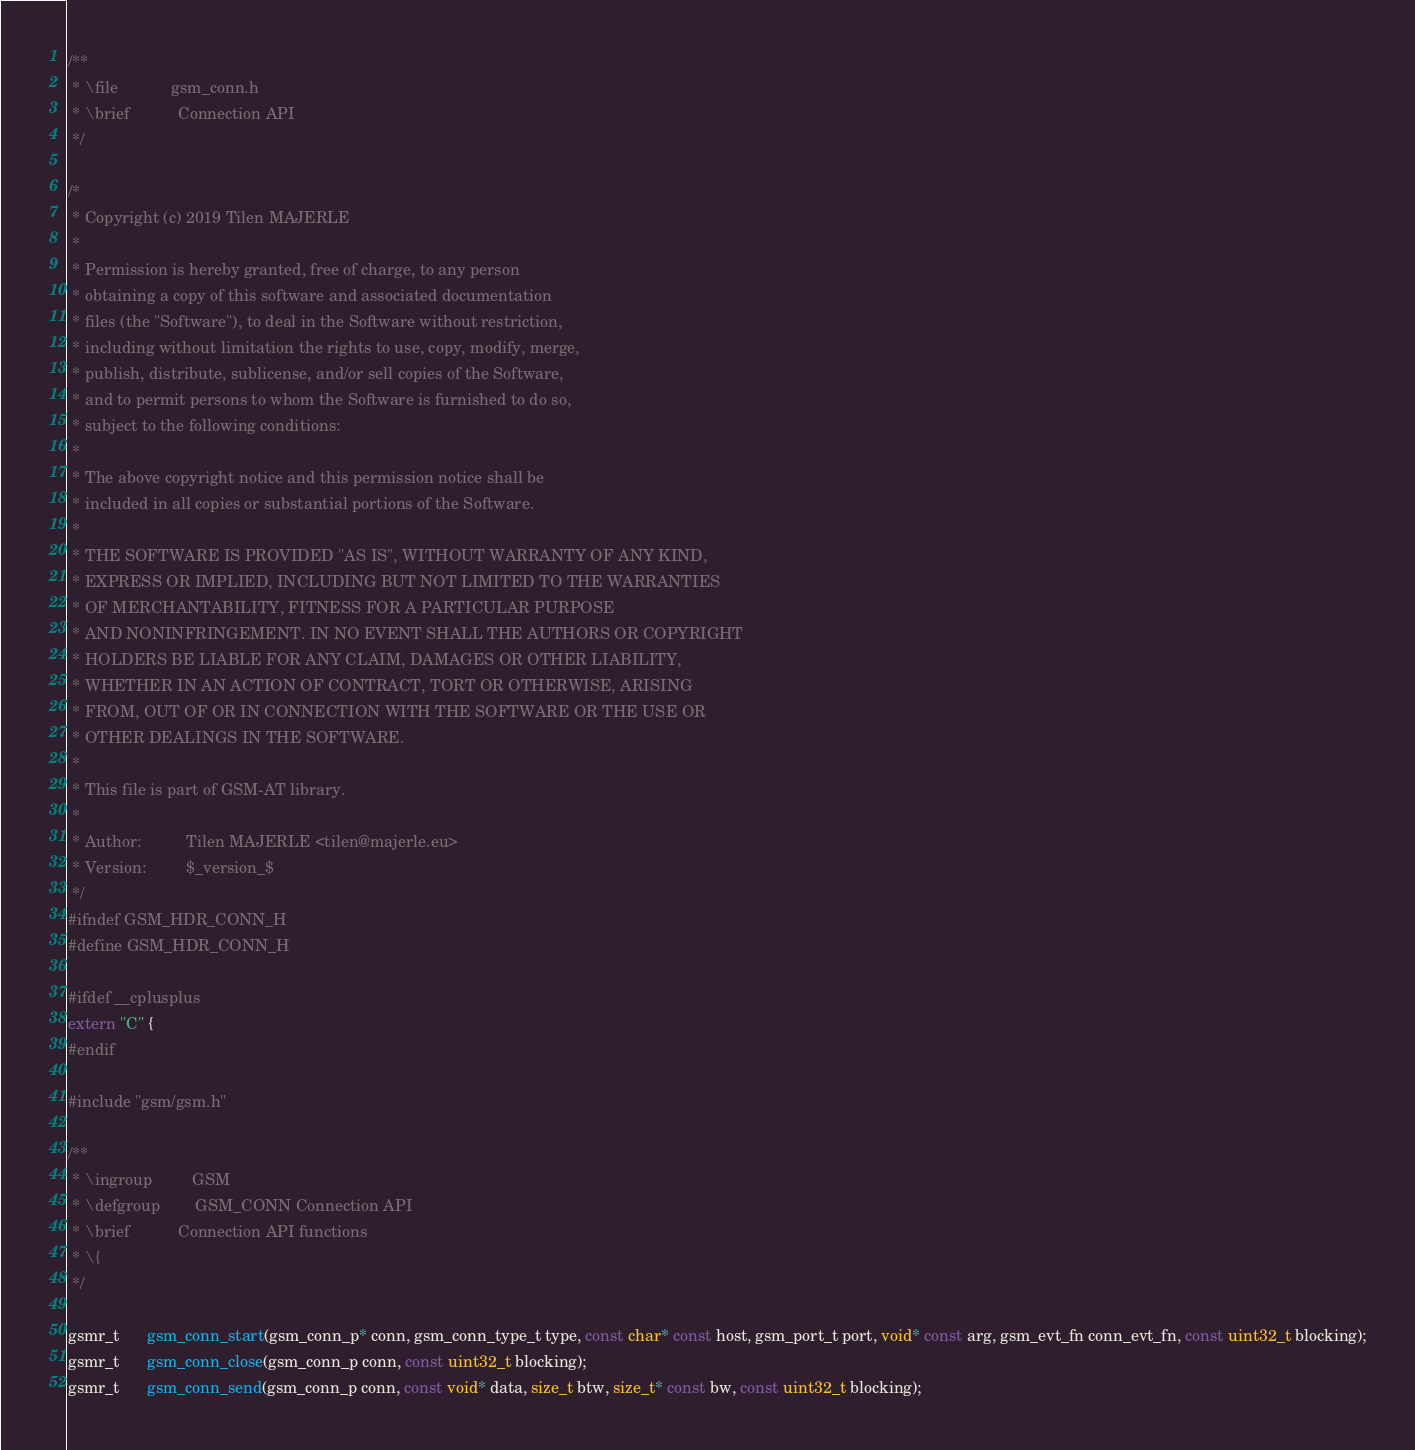<code> <loc_0><loc_0><loc_500><loc_500><_C_>/**
 * \file            gsm_conn.h
 * \brief           Connection API
 */

/*
 * Copyright (c) 2019 Tilen MAJERLE
 *
 * Permission is hereby granted, free of charge, to any person
 * obtaining a copy of this software and associated documentation
 * files (the "Software"), to deal in the Software without restriction,
 * including without limitation the rights to use, copy, modify, merge,
 * publish, distribute, sublicense, and/or sell copies of the Software,
 * and to permit persons to whom the Software is furnished to do so,
 * subject to the following conditions:
 *
 * The above copyright notice and this permission notice shall be
 * included in all copies or substantial portions of the Software.
 *
 * THE SOFTWARE IS PROVIDED "AS IS", WITHOUT WARRANTY OF ANY KIND,
 * EXPRESS OR IMPLIED, INCLUDING BUT NOT LIMITED TO THE WARRANTIES
 * OF MERCHANTABILITY, FITNESS FOR A PARTICULAR PURPOSE
 * AND NONINFRINGEMENT. IN NO EVENT SHALL THE AUTHORS OR COPYRIGHT
 * HOLDERS BE LIABLE FOR ANY CLAIM, DAMAGES OR OTHER LIABILITY,
 * WHETHER IN AN ACTION OF CONTRACT, TORT OR OTHERWISE, ARISING
 * FROM, OUT OF OR IN CONNECTION WITH THE SOFTWARE OR THE USE OR
 * OTHER DEALINGS IN THE SOFTWARE.
 *
 * This file is part of GSM-AT library.
 *
 * Author:          Tilen MAJERLE <tilen@majerle.eu>
 * Version:         $_version_$
 */
#ifndef GSM_HDR_CONN_H
#define GSM_HDR_CONN_H

#ifdef __cplusplus
extern "C" {
#endif

#include "gsm/gsm.h"

/**
 * \ingroup         GSM
 * \defgroup        GSM_CONN Connection API
 * \brief           Connection API functions
 * \{
 */

gsmr_t      gsm_conn_start(gsm_conn_p* conn, gsm_conn_type_t type, const char* const host, gsm_port_t port, void* const arg, gsm_evt_fn conn_evt_fn, const uint32_t blocking);
gsmr_t      gsm_conn_close(gsm_conn_p conn, const uint32_t blocking);
gsmr_t      gsm_conn_send(gsm_conn_p conn, const void* data, size_t btw, size_t* const bw, const uint32_t blocking);</code> 